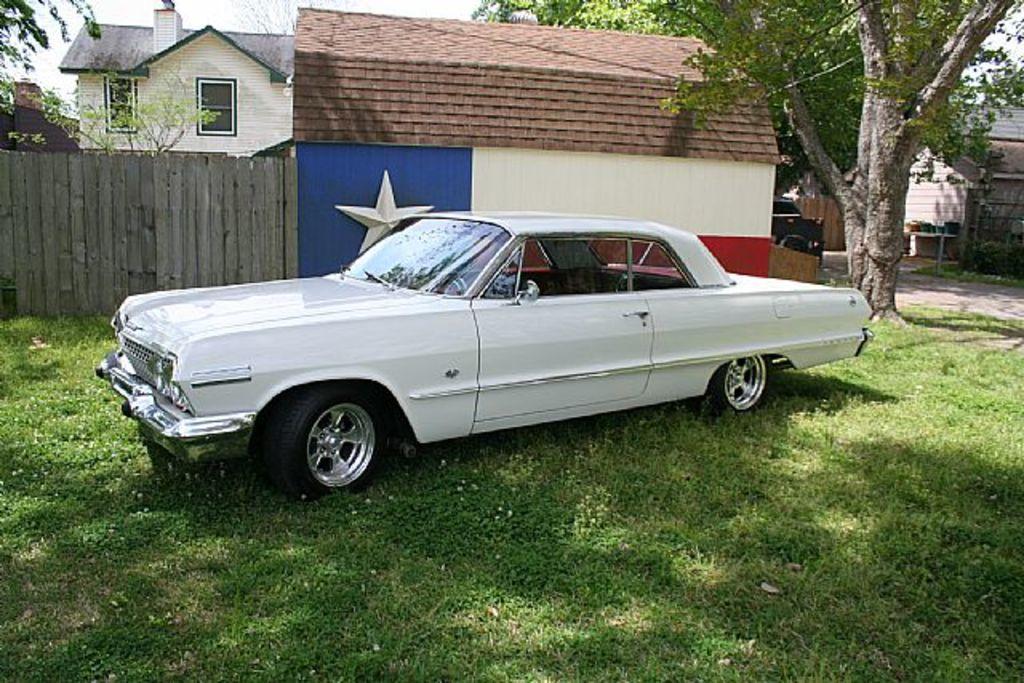In one or two sentences, can you explain what this image depicts? Here I can see a white color car on the ground. In the background there is a building along with the trees. At the bottom of the image I can see the grass. 